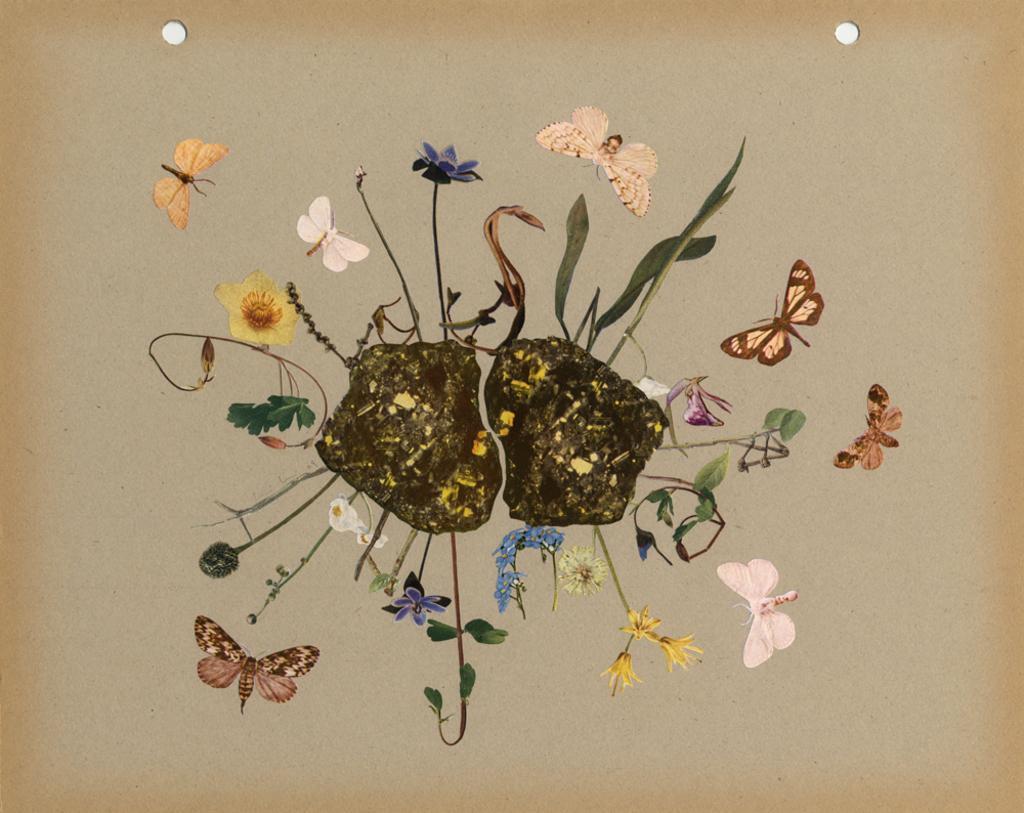Describe this image in one or two sentences. In this picture we can see a painting on paper and on this paper we can see butterflies, flowers and leaves. 